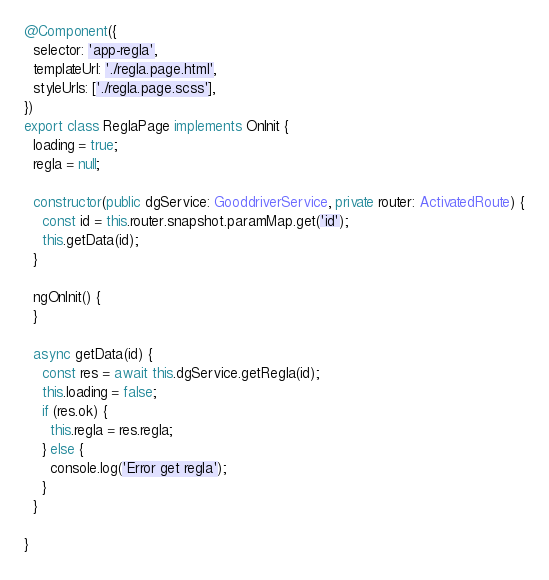Convert code to text. <code><loc_0><loc_0><loc_500><loc_500><_TypeScript_>
@Component({
  selector: 'app-regla',
  templateUrl: './regla.page.html',
  styleUrls: ['./regla.page.scss'],
})
export class ReglaPage implements OnInit {
  loading = true;
  regla = null;

  constructor(public dgService: GooddriverService, private router: ActivatedRoute) {
    const id = this.router.snapshot.paramMap.get('id');
    this.getData(id);
  }

  ngOnInit() {
  }

  async getData(id) {
    const res = await this.dgService.getRegla(id);
    this.loading = false;
    if (res.ok) {
      this.regla = res.regla;
    } else {
      console.log('Error get regla');
    }
  }

}
</code> 